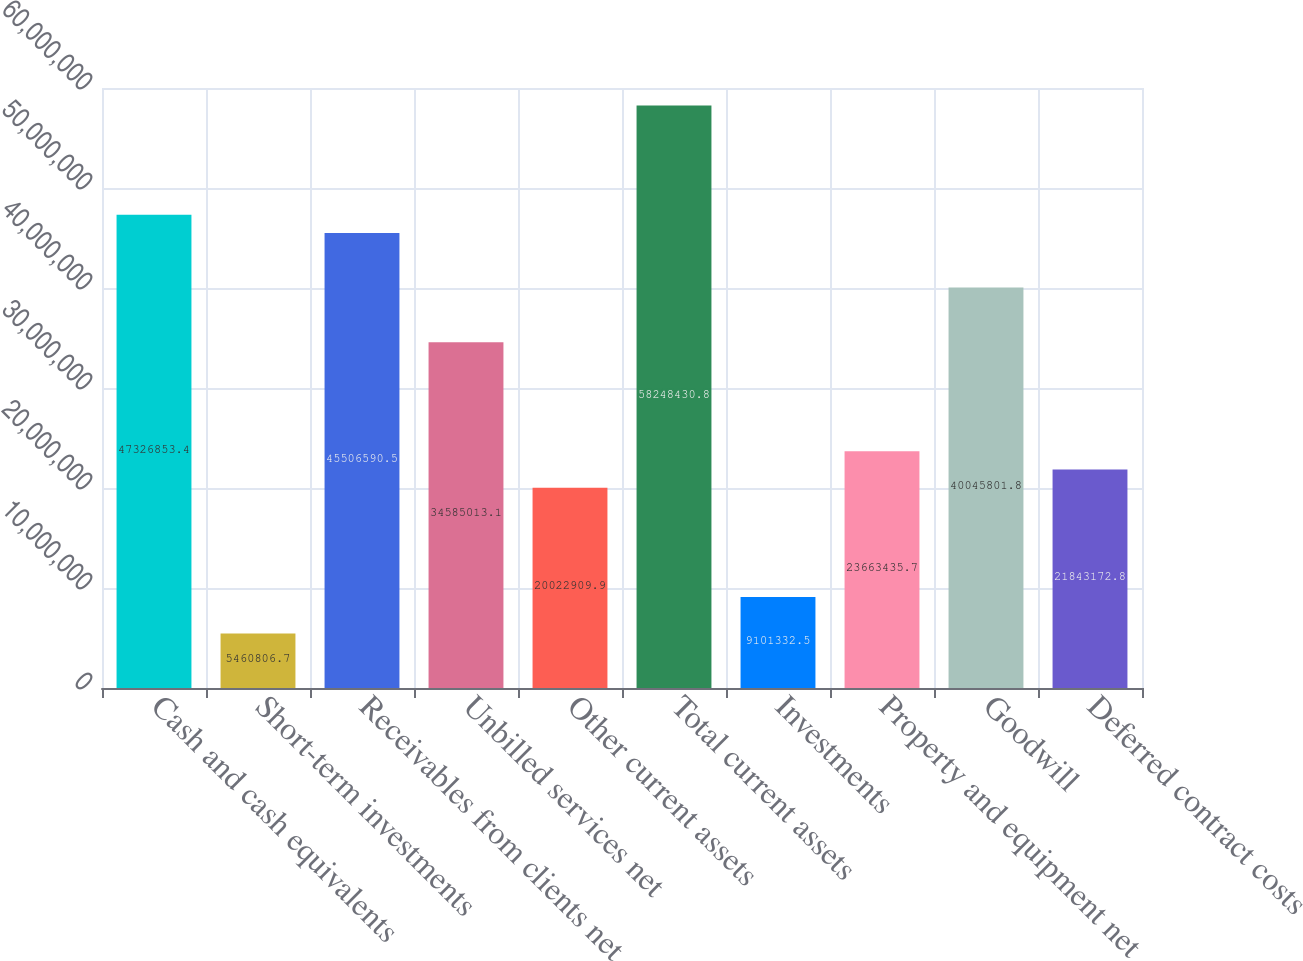Convert chart. <chart><loc_0><loc_0><loc_500><loc_500><bar_chart><fcel>Cash and cash equivalents<fcel>Short-term investments<fcel>Receivables from clients net<fcel>Unbilled services net<fcel>Other current assets<fcel>Total current assets<fcel>Investments<fcel>Property and equipment net<fcel>Goodwill<fcel>Deferred contract costs<nl><fcel>4.73269e+07<fcel>5.46081e+06<fcel>4.55066e+07<fcel>3.4585e+07<fcel>2.00229e+07<fcel>5.82484e+07<fcel>9.10133e+06<fcel>2.36634e+07<fcel>4.00458e+07<fcel>2.18432e+07<nl></chart> 